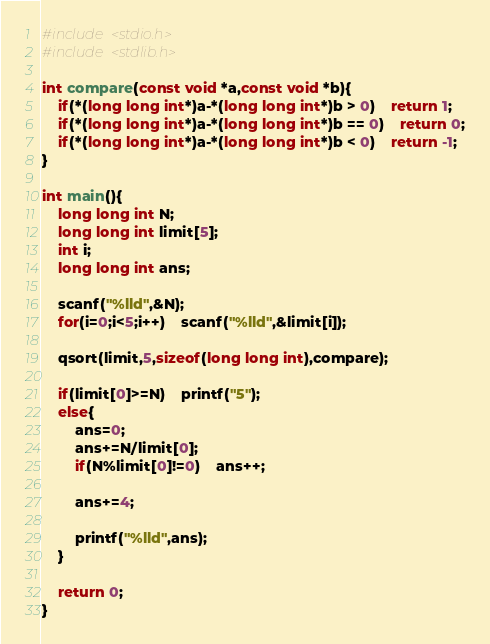Convert code to text. <code><loc_0><loc_0><loc_500><loc_500><_C_>#include <stdio.h>
#include <stdlib.h>

int compare(const void *a,const void *b){
	if(*(long long int*)a-*(long long int*)b > 0)	return 1;
	if(*(long long int*)a-*(long long int*)b == 0)	return 0;
	if(*(long long int*)a-*(long long int*)b < 0)	return -1;
}

int main(){
	long long int N;
	long long int limit[5];
	int i;
	long long int ans;
	
	scanf("%lld",&N);
	for(i=0;i<5;i++)	scanf("%lld",&limit[i]);
	
	qsort(limit,5,sizeof(long long int),compare);
	
	if(limit[0]>=N)	printf("5");
	else{
		ans=0;
		ans+=N/limit[0];
		if(N%limit[0]!=0)	ans++;
		
		ans+=4;
		
		printf("%lld",ans);
	}
	
	return 0;
}
</code> 